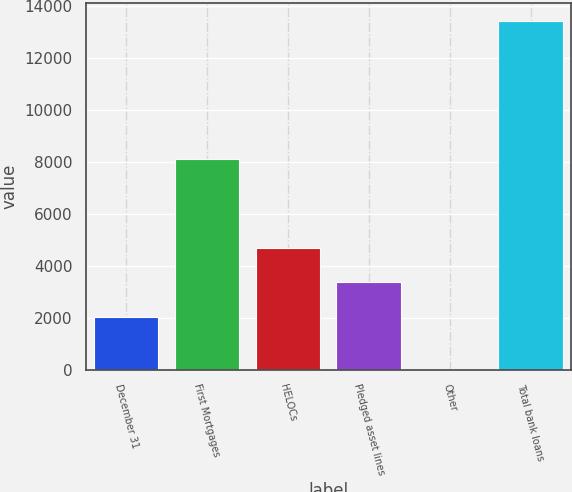<chart> <loc_0><loc_0><loc_500><loc_500><bar_chart><fcel>December 31<fcel>First Mortgages<fcel>HELOCs<fcel>Pledged asset lines<fcel>Other<fcel>Total bank loans<nl><fcel>2014<fcel>8127<fcel>4694.4<fcel>3354.2<fcel>39<fcel>13441<nl></chart> 